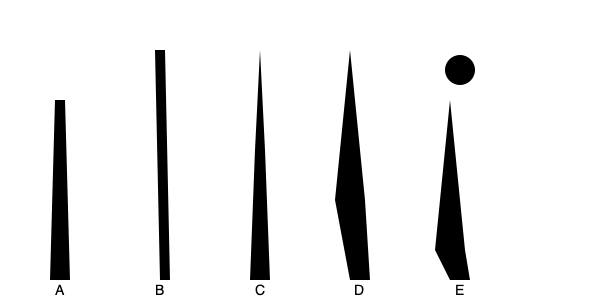Arrange the minaret designs A, B, C, D, and E in chronological order from earliest to latest, based on their architectural evolution. To arrange the minaret designs chronologically, we need to consider the evolution of Islamic architecture:

1. Minaret A represents the earliest design, typical of the 7th-8th century. It's a simple, cylindrical shape without much ornamentation, common in early mosques like the Great Mosque of Kairouan.

2. Minaret B shows a slightly more refined design with a tapered top, characteristic of the 9th-10th century. This style is seen in the Ibn Tulun Mosque in Cairo.

3. Minaret C displays a more complex structure with a bulbous top, typical of the 11th-12th century Seljuk architecture, as seen in the Great Mosque of Isfahan.

4. Minaret D showcases multiple balconies and a more elaborate silhouette, representative of the 13th-14th century Mamluk style, exemplified by minarets in Cairo.

5. Minaret E is the most ornate, with a distinctive onion dome on top, typical of the 15th-16th century Ottoman style, as seen in the Blue Mosque in Istanbul.

Each subsequent design shows increasing complexity and regional influences, reflecting the spread and evolution of Islamic architecture over time.
Answer: A, B, C, D, E 